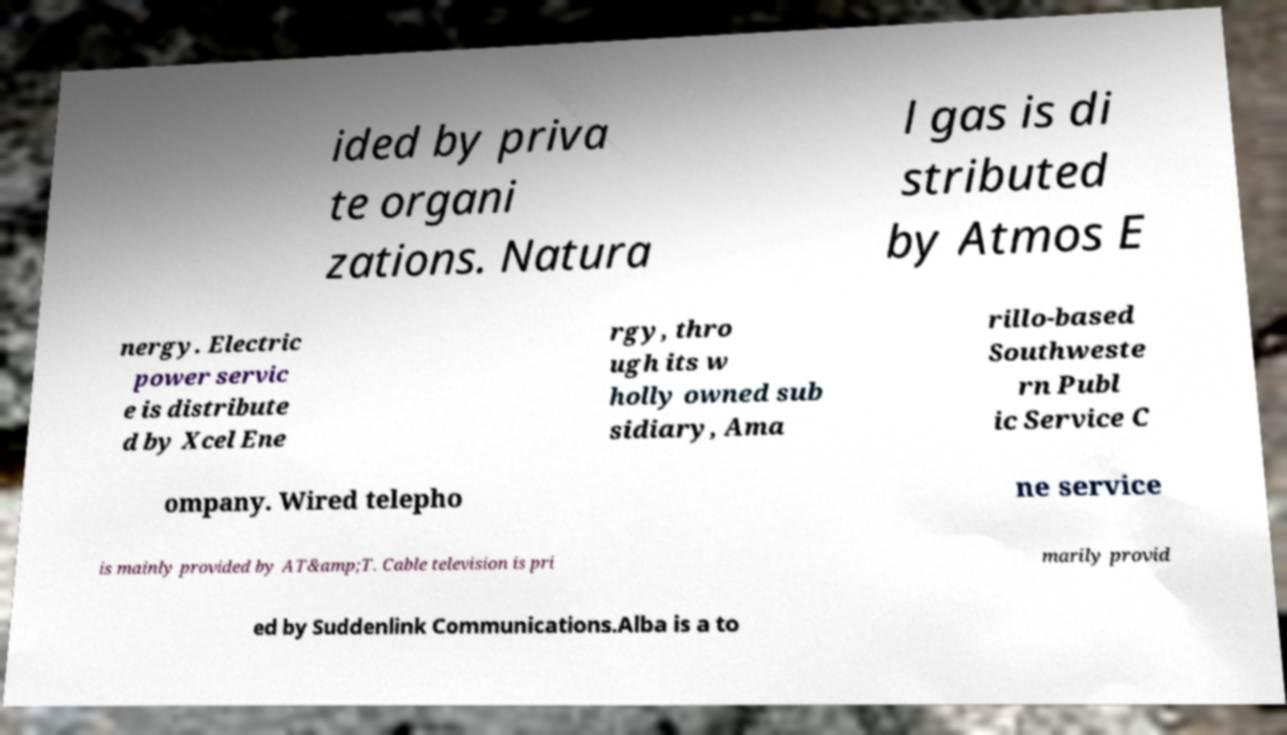Could you assist in decoding the text presented in this image and type it out clearly? ided by priva te organi zations. Natura l gas is di stributed by Atmos E nergy. Electric power servic e is distribute d by Xcel Ene rgy, thro ugh its w holly owned sub sidiary, Ama rillo-based Southweste rn Publ ic Service C ompany. Wired telepho ne service is mainly provided by AT&amp;T. Cable television is pri marily provid ed by Suddenlink Communications.Alba is a to 